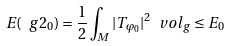<formula> <loc_0><loc_0><loc_500><loc_500>E ( \ g 2 _ { 0 } ) = \frac { 1 } { 2 } \int _ { M } | T _ { \varphi _ { 0 } } | ^ { 2 } \ v o l _ { g } \leq E _ { 0 }</formula> 